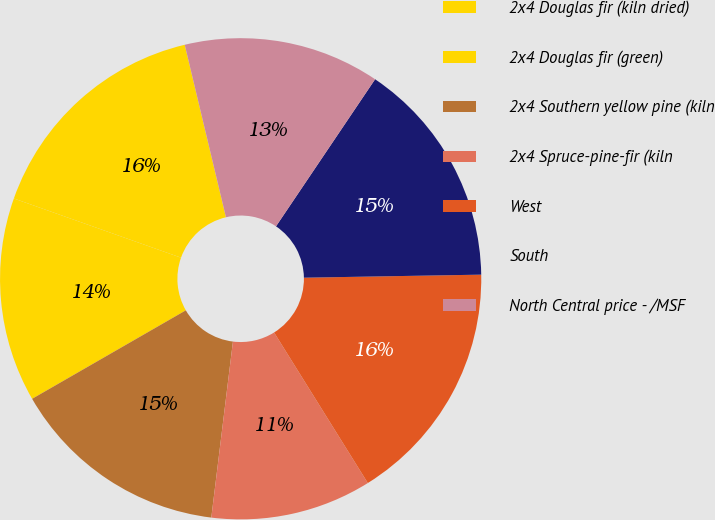<chart> <loc_0><loc_0><loc_500><loc_500><pie_chart><fcel>2x4 Douglas fir (kiln dried)<fcel>2x4 Douglas fir (green)<fcel>2x4 Southern yellow pine (kiln<fcel>2x4 Spruce-pine-fir (kiln<fcel>West<fcel>South<fcel>North Central price - /MSF<nl><fcel>15.85%<fcel>13.73%<fcel>14.74%<fcel>10.81%<fcel>16.41%<fcel>15.29%<fcel>13.17%<nl></chart> 